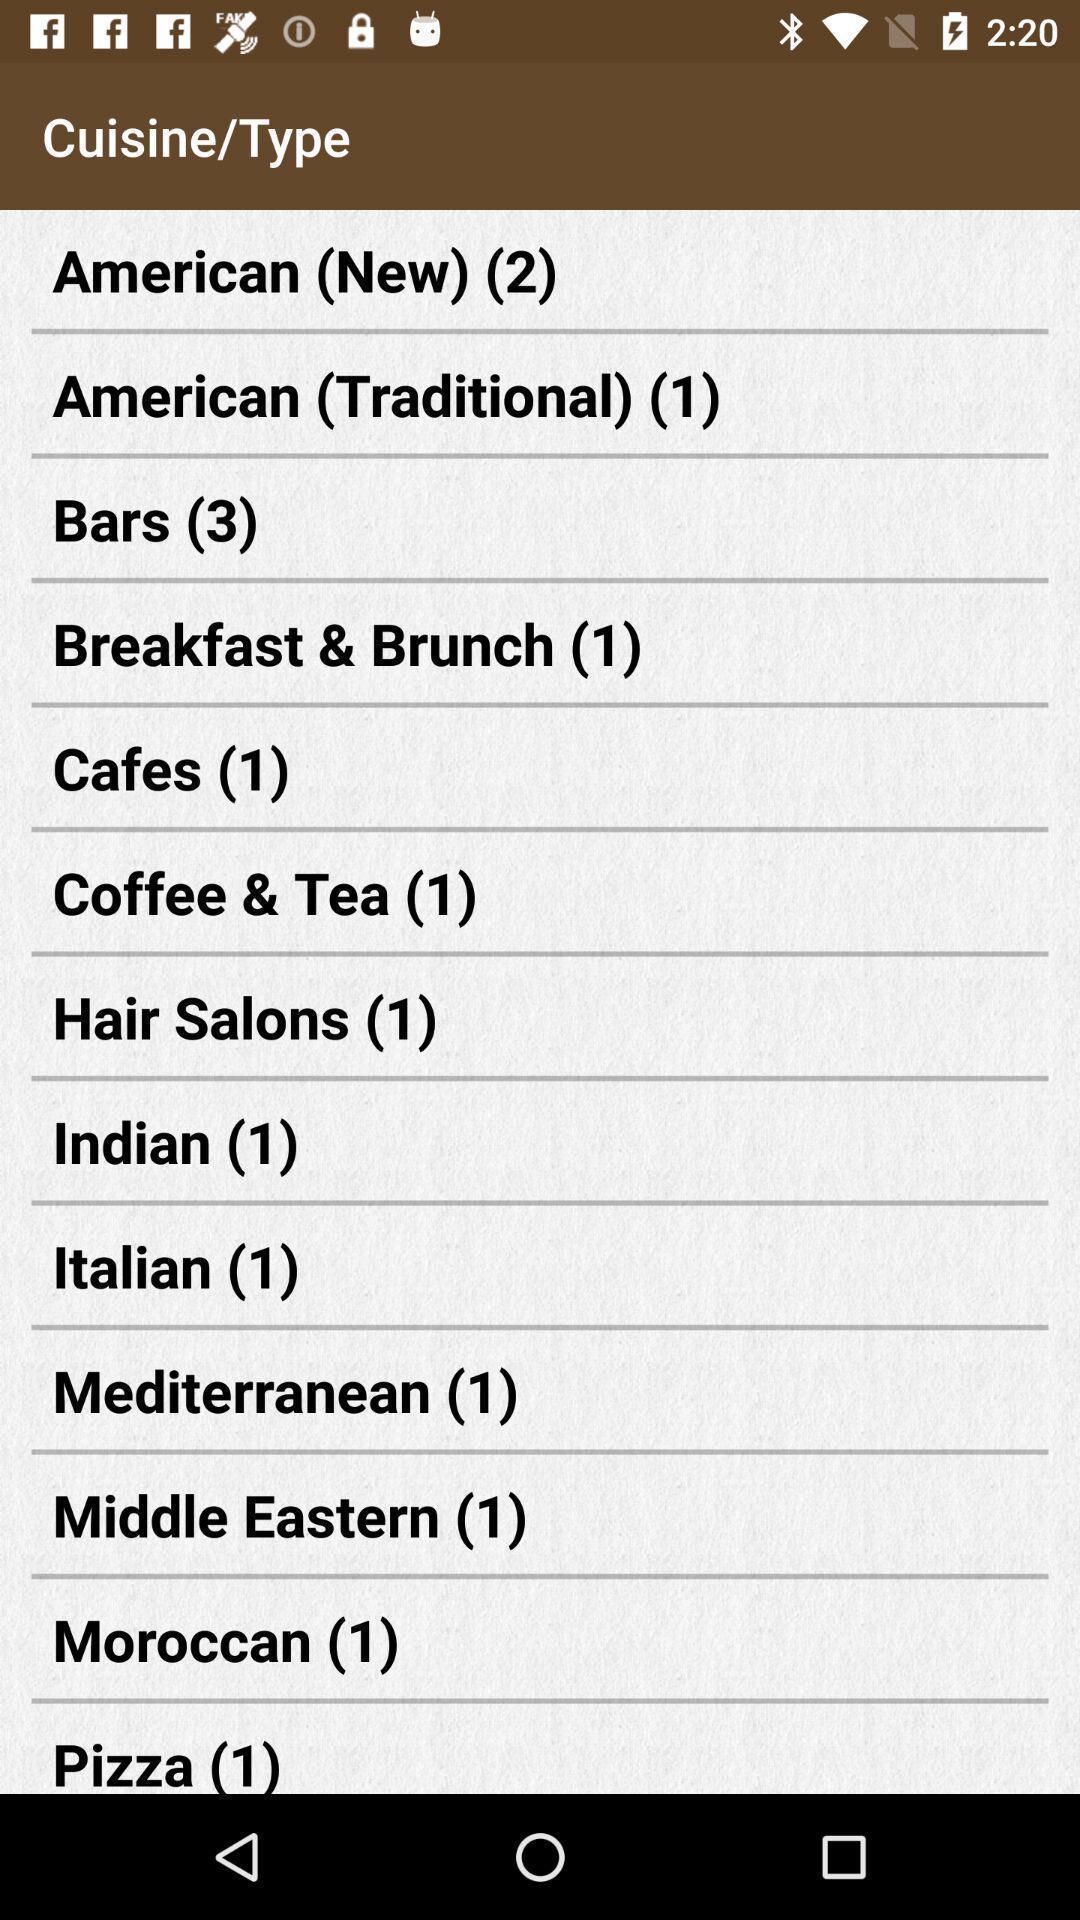Give me a summary of this screen capture. Screen displaying a list of cuisine names. 